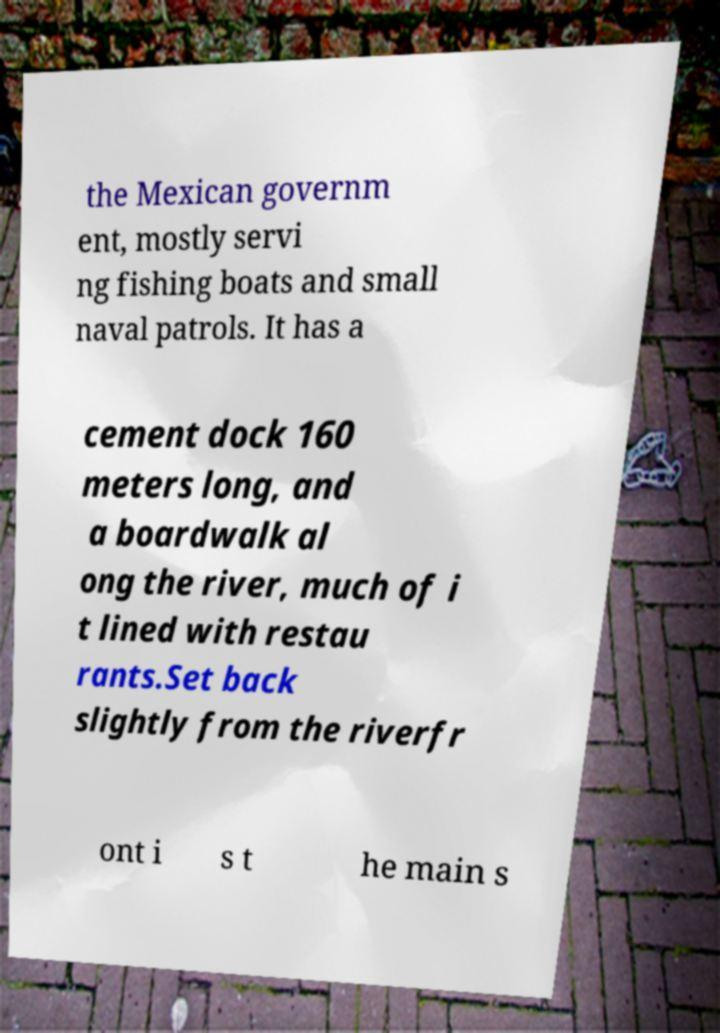I need the written content from this picture converted into text. Can you do that? the Mexican governm ent, mostly servi ng fishing boats and small naval patrols. It has a cement dock 160 meters long, and a boardwalk al ong the river, much of i t lined with restau rants.Set back slightly from the riverfr ont i s t he main s 